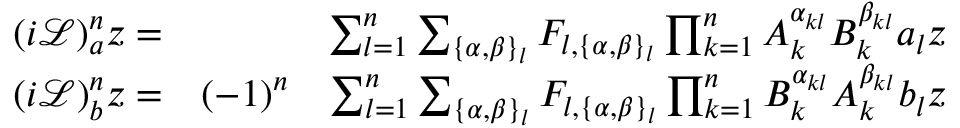Convert formula to latex. <formula><loc_0><loc_0><loc_500><loc_500>\begin{array} { r l r } { ( i \mathcal { L } ) _ { a } ^ { n } z = } & { \sum _ { l = 1 } ^ { n } \sum _ { \{ \alpha , \beta \} _ { l } } F _ { l , \{ \alpha , \beta \} _ { l } } \prod _ { k = 1 } ^ { n } A _ { k } ^ { \alpha _ { k l } } B _ { k } ^ { \beta _ { k l } } a _ { l } z } \\ { ( i \mathcal { L } ) _ { b } ^ { n } z = } & { ( - 1 ) ^ { n } } & { \sum _ { l = 1 } ^ { n } \sum _ { \{ \alpha , \beta \} _ { l } } F _ { l , \{ \alpha , \beta \} _ { l } } \prod _ { k = 1 } ^ { n } B _ { k } ^ { \alpha _ { k l } } A _ { k } ^ { \beta _ { k l } } b _ { l } z } \end{array}</formula> 